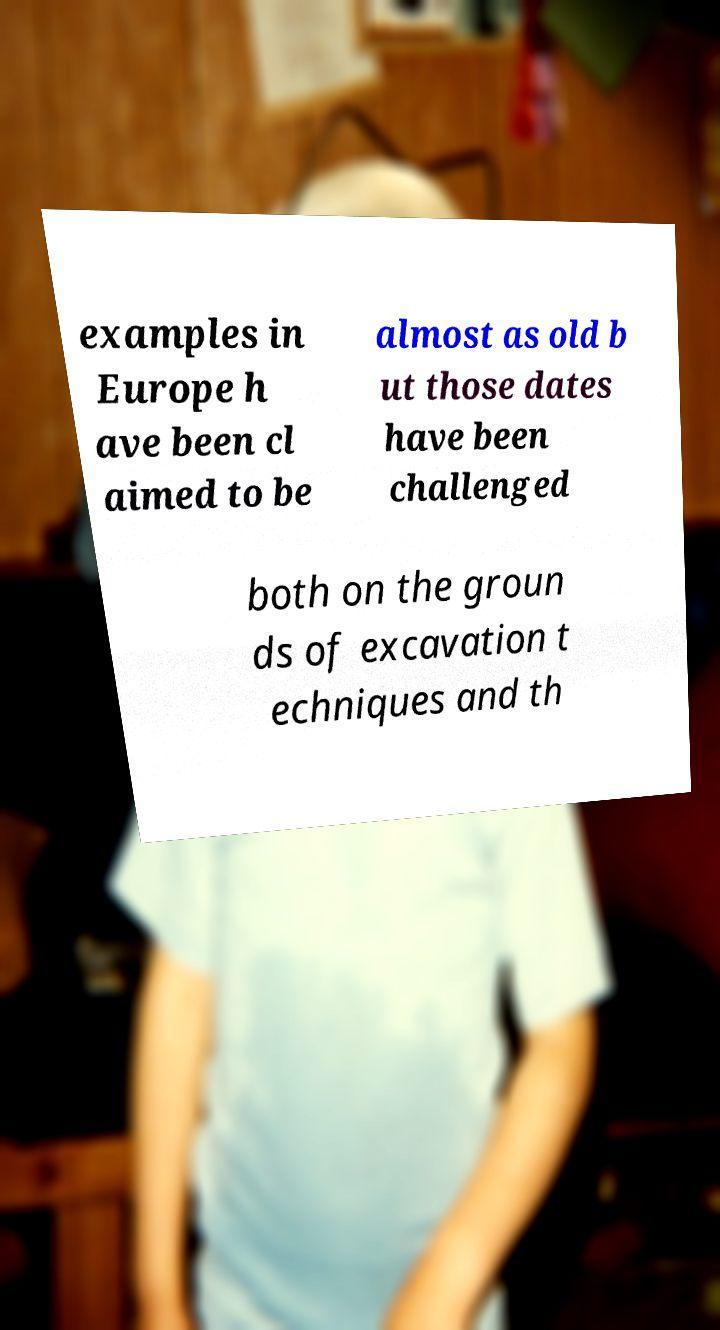Can you accurately transcribe the text from the provided image for me? examples in Europe h ave been cl aimed to be almost as old b ut those dates have been challenged both on the groun ds of excavation t echniques and th 